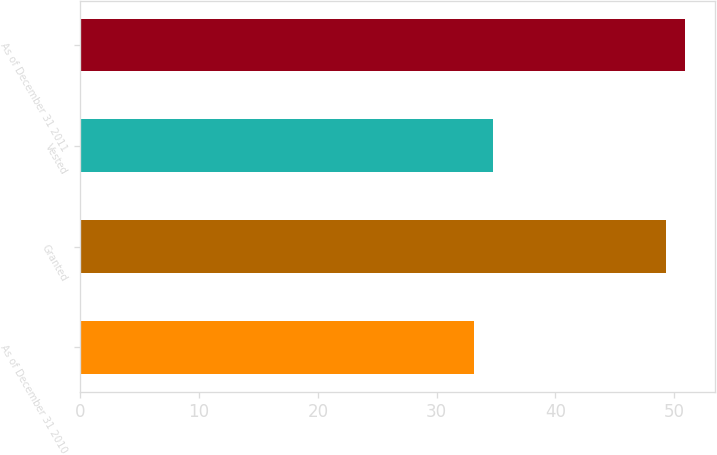<chart> <loc_0><loc_0><loc_500><loc_500><bar_chart><fcel>As of December 31 2010<fcel>Granted<fcel>Vested<fcel>As of December 31 2011<nl><fcel>33.13<fcel>49.3<fcel>34.75<fcel>50.92<nl></chart> 